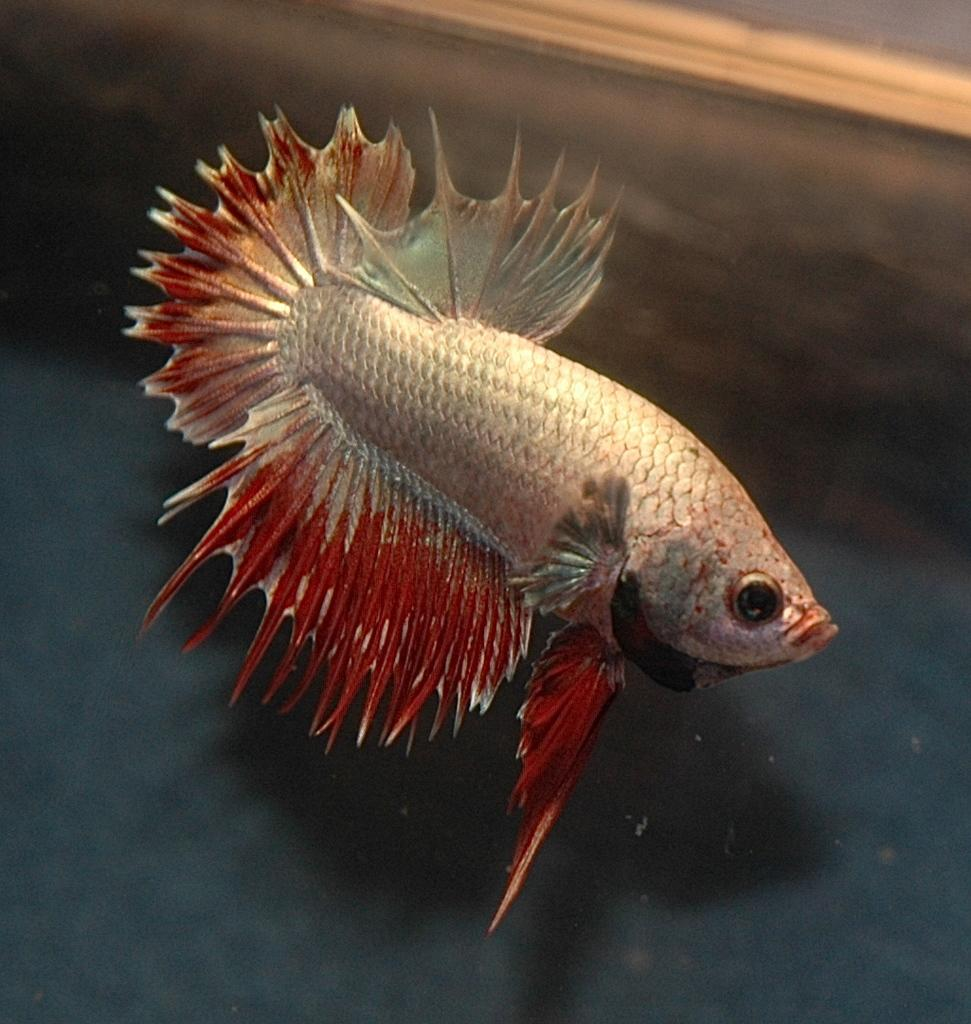What is the main subject of the image? The main subject of the image is a fish. Where is the fish located in the image? The fish is in the center of the image. What is the environment surrounding the fish? The fish is in the water. What type of mark can be seen on the fish in the image? There is no mark visible on the fish in the image. What type of eggnog is being served with the fish in the image? There is no eggnog present in the image; it only features a fish in the water. 